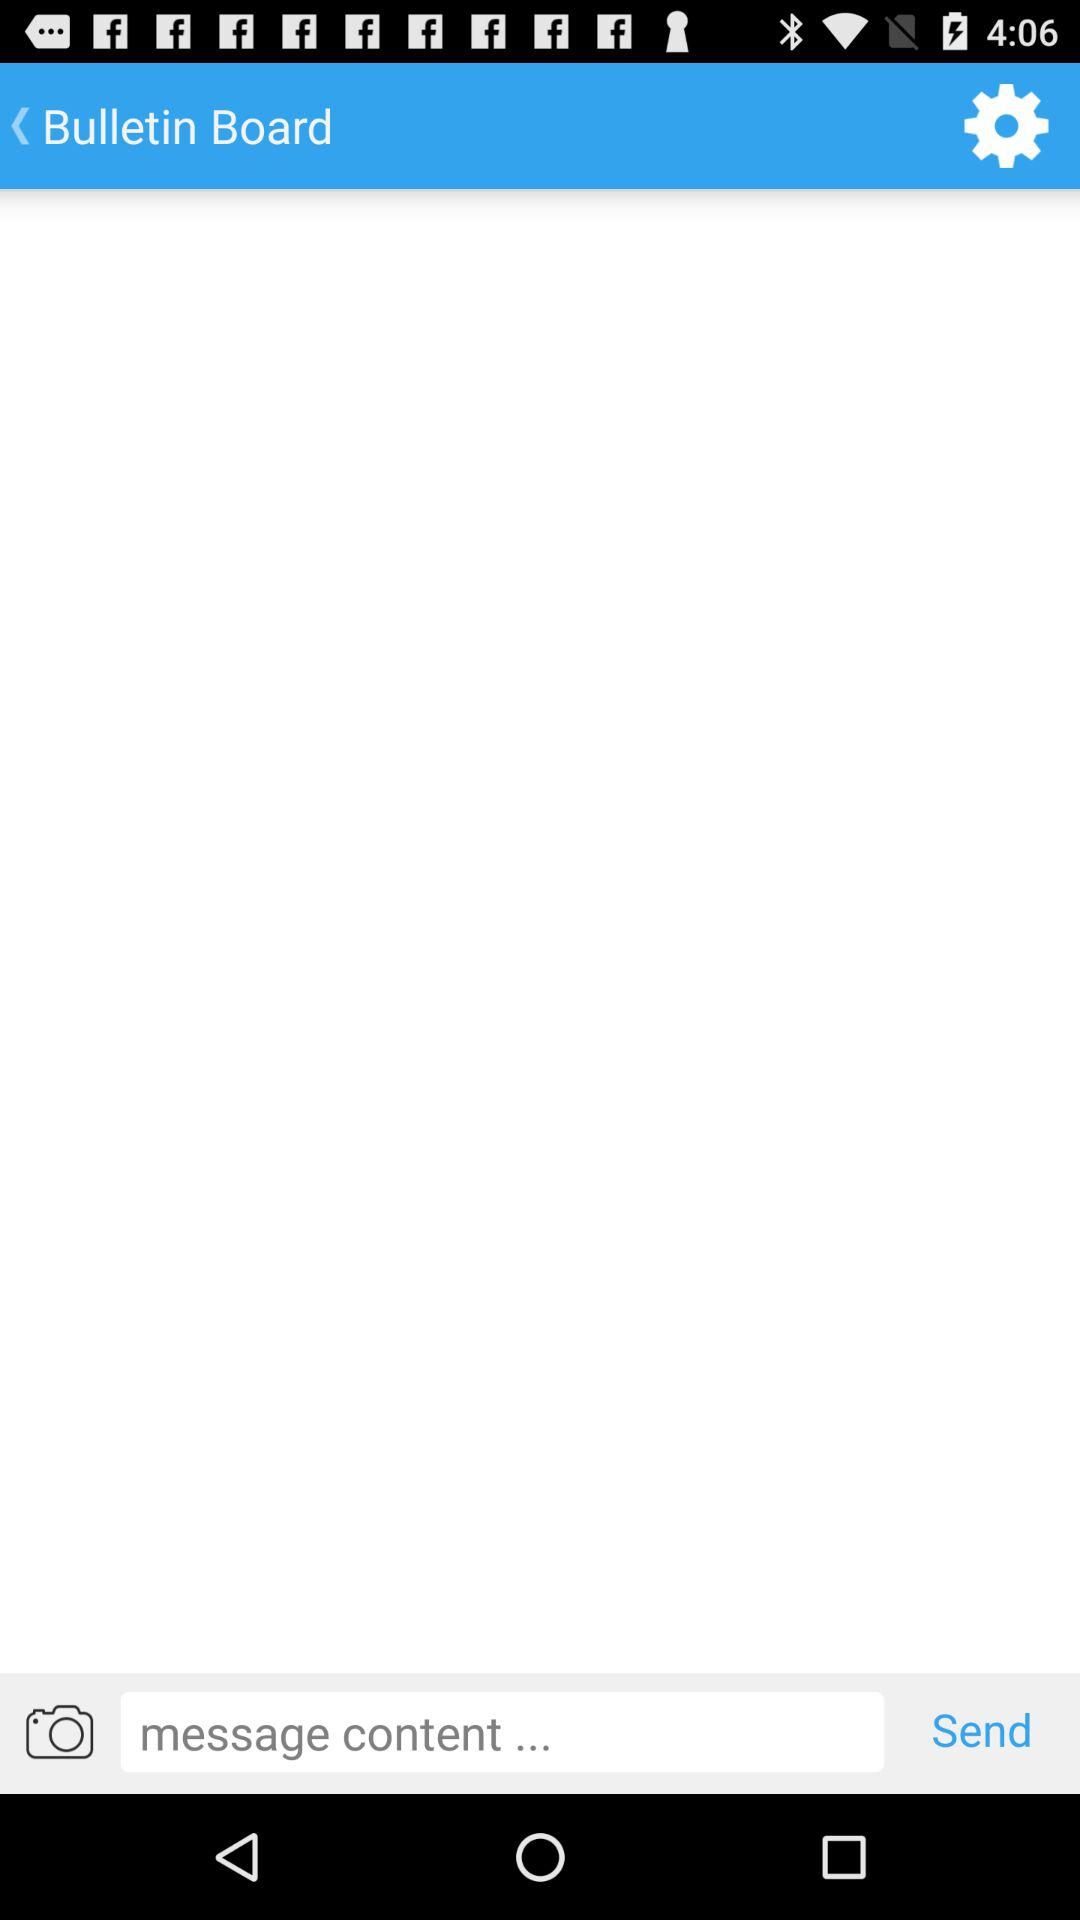What is the application name?
When the provided information is insufficient, respond with <no answer>. <no answer> 